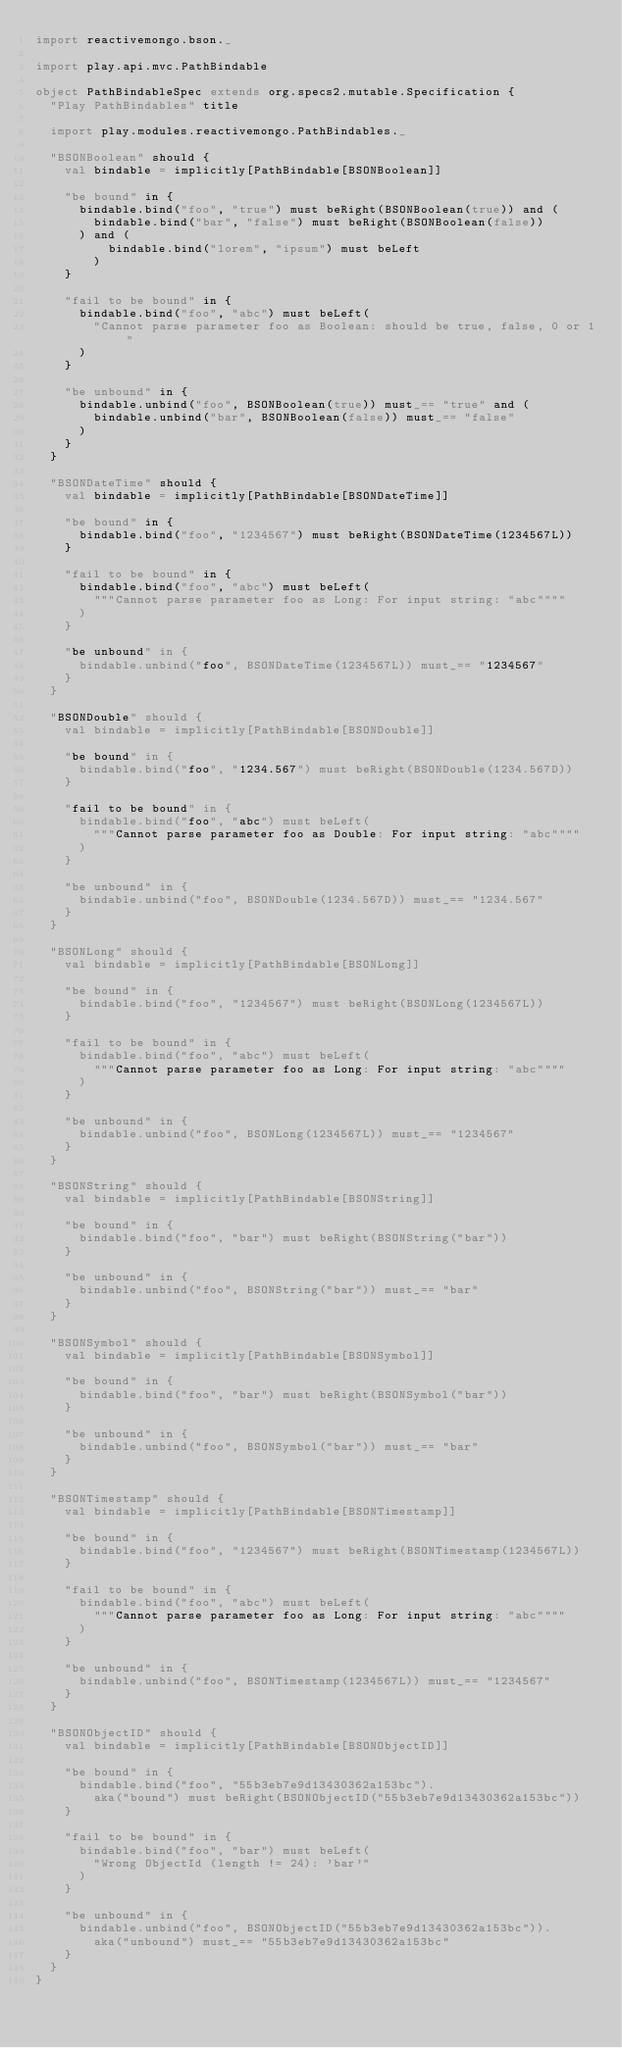<code> <loc_0><loc_0><loc_500><loc_500><_Scala_>import reactivemongo.bson._

import play.api.mvc.PathBindable

object PathBindableSpec extends org.specs2.mutable.Specification {
  "Play PathBindables" title

  import play.modules.reactivemongo.PathBindables._

  "BSONBoolean" should {
    val bindable = implicitly[PathBindable[BSONBoolean]]

    "be bound" in {
      bindable.bind("foo", "true") must beRight(BSONBoolean(true)) and (
        bindable.bind("bar", "false") must beRight(BSONBoolean(false))
      ) and (
          bindable.bind("lorem", "ipsum") must beLeft
        )
    }

    "fail to be bound" in {
      bindable.bind("foo", "abc") must beLeft(
        "Cannot parse parameter foo as Boolean: should be true, false, 0 or 1"
      )
    }

    "be unbound" in {
      bindable.unbind("foo", BSONBoolean(true)) must_== "true" and (
        bindable.unbind("bar", BSONBoolean(false)) must_== "false"
      )
    }
  }

  "BSONDateTime" should {
    val bindable = implicitly[PathBindable[BSONDateTime]]

    "be bound" in {
      bindable.bind("foo", "1234567") must beRight(BSONDateTime(1234567L))
    }

    "fail to be bound" in {
      bindable.bind("foo", "abc") must beLeft(
        """Cannot parse parameter foo as Long: For input string: "abc""""
      )
    }

    "be unbound" in {
      bindable.unbind("foo", BSONDateTime(1234567L)) must_== "1234567"
    }
  }

  "BSONDouble" should {
    val bindable = implicitly[PathBindable[BSONDouble]]

    "be bound" in {
      bindable.bind("foo", "1234.567") must beRight(BSONDouble(1234.567D))
    }

    "fail to be bound" in {
      bindable.bind("foo", "abc") must beLeft(
        """Cannot parse parameter foo as Double: For input string: "abc""""
      )
    }

    "be unbound" in {
      bindable.unbind("foo", BSONDouble(1234.567D)) must_== "1234.567"
    }
  }

  "BSONLong" should {
    val bindable = implicitly[PathBindable[BSONLong]]

    "be bound" in {
      bindable.bind("foo", "1234567") must beRight(BSONLong(1234567L))
    }

    "fail to be bound" in {
      bindable.bind("foo", "abc") must beLeft(
        """Cannot parse parameter foo as Long: For input string: "abc""""
      )
    }

    "be unbound" in {
      bindable.unbind("foo", BSONLong(1234567L)) must_== "1234567"
    }
  }

  "BSONString" should {
    val bindable = implicitly[PathBindable[BSONString]]

    "be bound" in {
      bindable.bind("foo", "bar") must beRight(BSONString("bar"))
    }

    "be unbound" in {
      bindable.unbind("foo", BSONString("bar")) must_== "bar"
    }
  }

  "BSONSymbol" should {
    val bindable = implicitly[PathBindable[BSONSymbol]]

    "be bound" in {
      bindable.bind("foo", "bar") must beRight(BSONSymbol("bar"))
    }

    "be unbound" in {
      bindable.unbind("foo", BSONSymbol("bar")) must_== "bar"
    }
  }

  "BSONTimestamp" should {
    val bindable = implicitly[PathBindable[BSONTimestamp]]

    "be bound" in {
      bindable.bind("foo", "1234567") must beRight(BSONTimestamp(1234567L))
    }

    "fail to be bound" in {
      bindable.bind("foo", "abc") must beLeft(
        """Cannot parse parameter foo as Long: For input string: "abc""""
      )
    }

    "be unbound" in {
      bindable.unbind("foo", BSONTimestamp(1234567L)) must_== "1234567"
    }
  }

  "BSONObjectID" should {
    val bindable = implicitly[PathBindable[BSONObjectID]]

    "be bound" in {
      bindable.bind("foo", "55b3eb7e9d13430362a153bc").
        aka("bound") must beRight(BSONObjectID("55b3eb7e9d13430362a153bc"))
    }

    "fail to be bound" in {
      bindable.bind("foo", "bar") must beLeft(
        "Wrong ObjectId (length != 24): 'bar'"
      )
    }

    "be unbound" in {
      bindable.unbind("foo", BSONObjectID("55b3eb7e9d13430362a153bc")).
        aka("unbound") must_== "55b3eb7e9d13430362a153bc"
    }
  }
}
</code> 